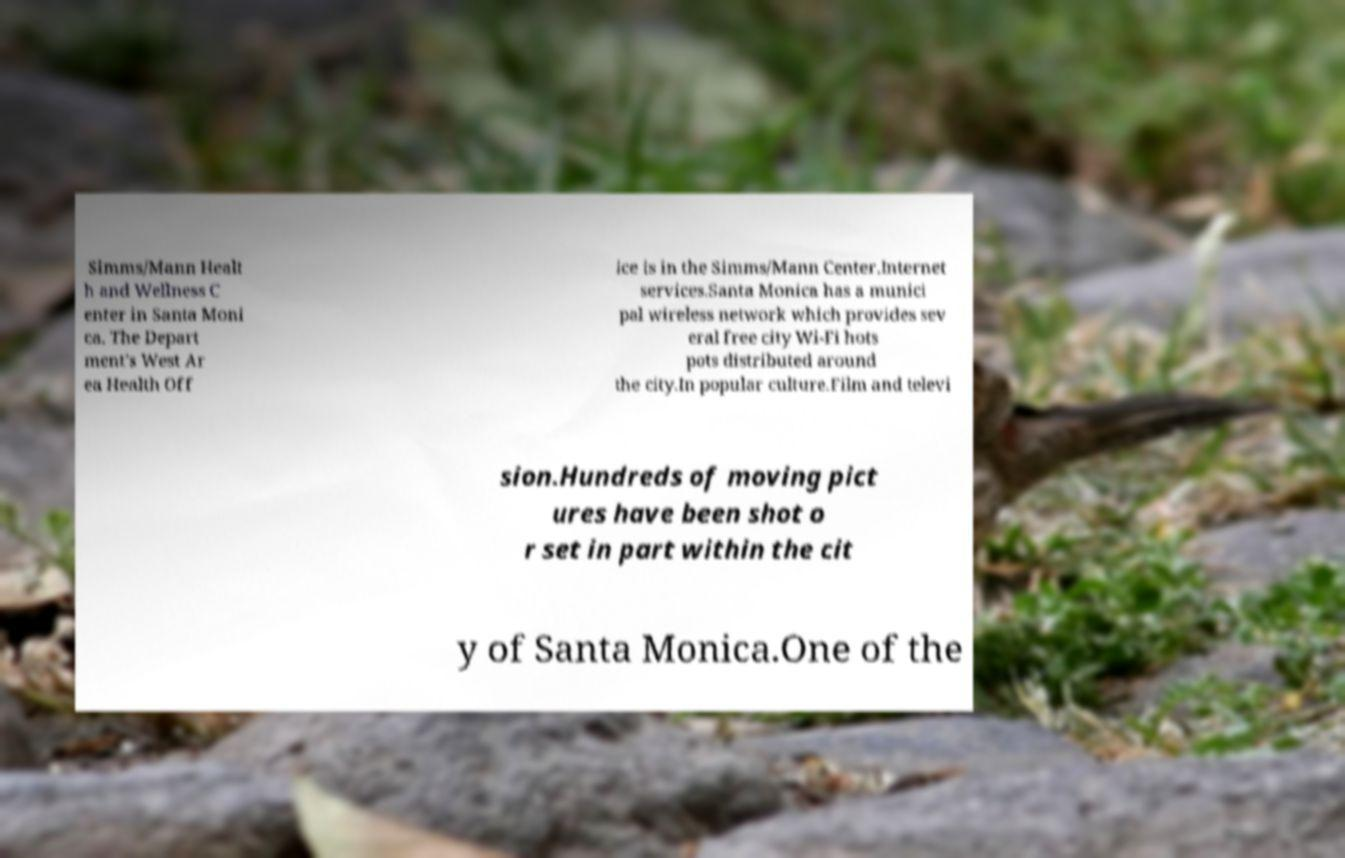Please read and relay the text visible in this image. What does it say? Simms/Mann Healt h and Wellness C enter in Santa Moni ca. The Depart ment's West Ar ea Health Off ice is in the Simms/Mann Center.Internet services.Santa Monica has a munici pal wireless network which provides sev eral free city Wi-Fi hots pots distributed around the city.In popular culture.Film and televi sion.Hundreds of moving pict ures have been shot o r set in part within the cit y of Santa Monica.One of the 